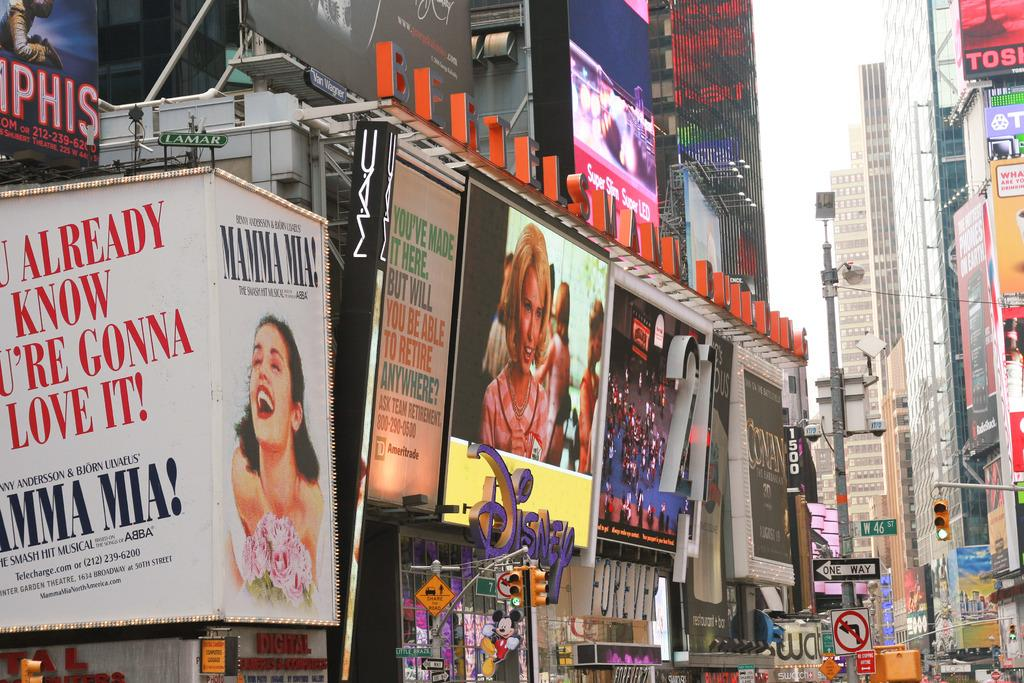What type of signage can be seen in the image? There are hoardings in the image. What helps regulate traffic in the image? There are traffic lights in the image. What type of structures are visible in the image? There are buildings in the image. Can you describe any other objects present in the image? There are other objects present in the image, but their specific details are not mentioned in the provided facts. Where is the board located in the image? There is no board mentioned in the provided facts, so it cannot be located in the image. What type of lamp can be seen illuminating the area in the image? There is no lamp present in the image, as the provided facts only mention hoardings, traffic lights, and buildings. 